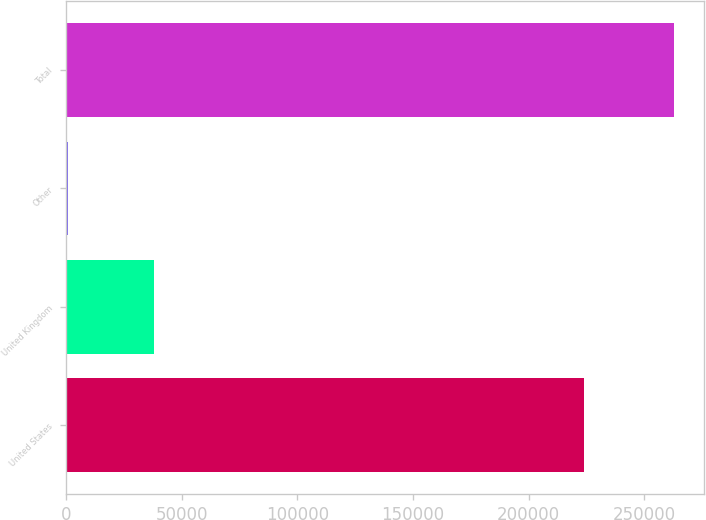<chart> <loc_0><loc_0><loc_500><loc_500><bar_chart><fcel>United States<fcel>United Kingdom<fcel>Other<fcel>Total<nl><fcel>223741<fcel>38189<fcel>844<fcel>262774<nl></chart> 